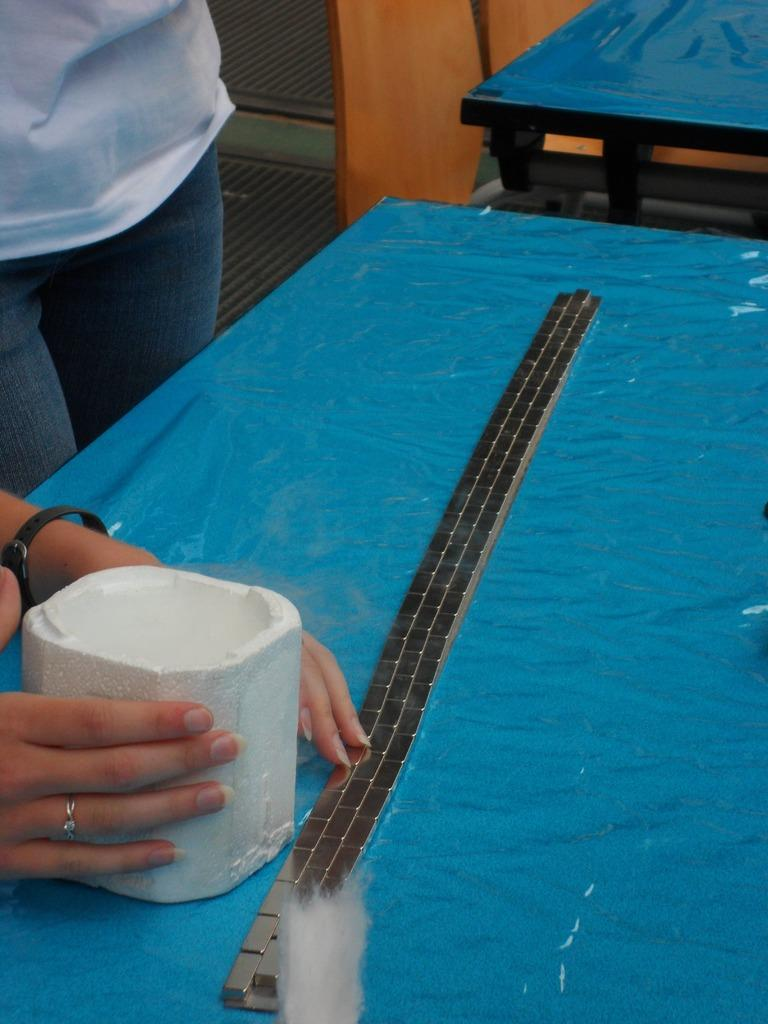What is the main object in the image? There is a table in the image. Who is present in the image? There is a woman in the image. What is the woman doing in the image? The woman has her hands on the table. How many girls are sitting on the chair in the image? There is no chair or girls present in the image. What type of ear is visible on the woman in the image? The image does not show the woman's ears, so it cannot be determined what type of ear is visible. 